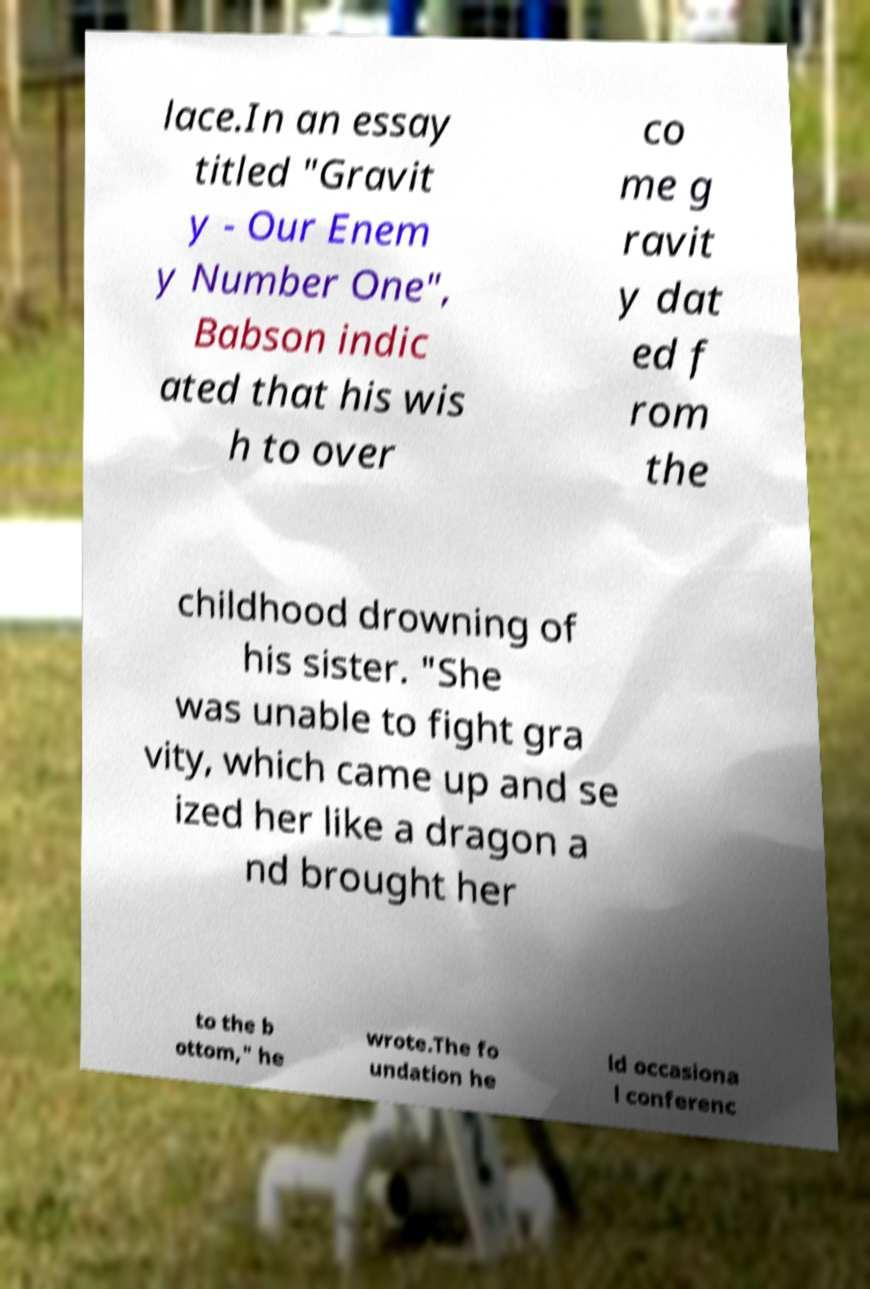Can you accurately transcribe the text from the provided image for me? lace.In an essay titled "Gravit y - Our Enem y Number One", Babson indic ated that his wis h to over co me g ravit y dat ed f rom the childhood drowning of his sister. "She was unable to fight gra vity, which came up and se ized her like a dragon a nd brought her to the b ottom," he wrote.The fo undation he ld occasiona l conferenc 